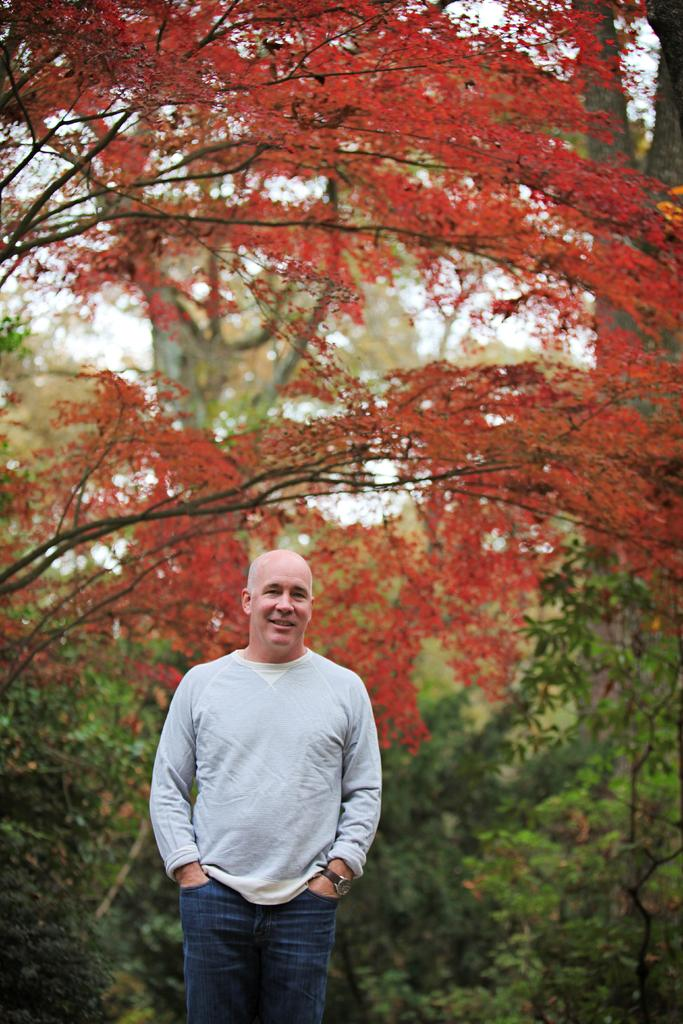What is the main subject of the image? There is a man standing in the image. What can be seen in the background of the image? There are trees visible in the background of the image. What colors are present on the leaves of the trees? The leaves on the trees have red and green colors. How many sisters does the man have in the image? There is no information about the man's sisters in the image. 